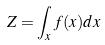<formula> <loc_0><loc_0><loc_500><loc_500>Z = \int _ { x } f ( x ) d x</formula> 